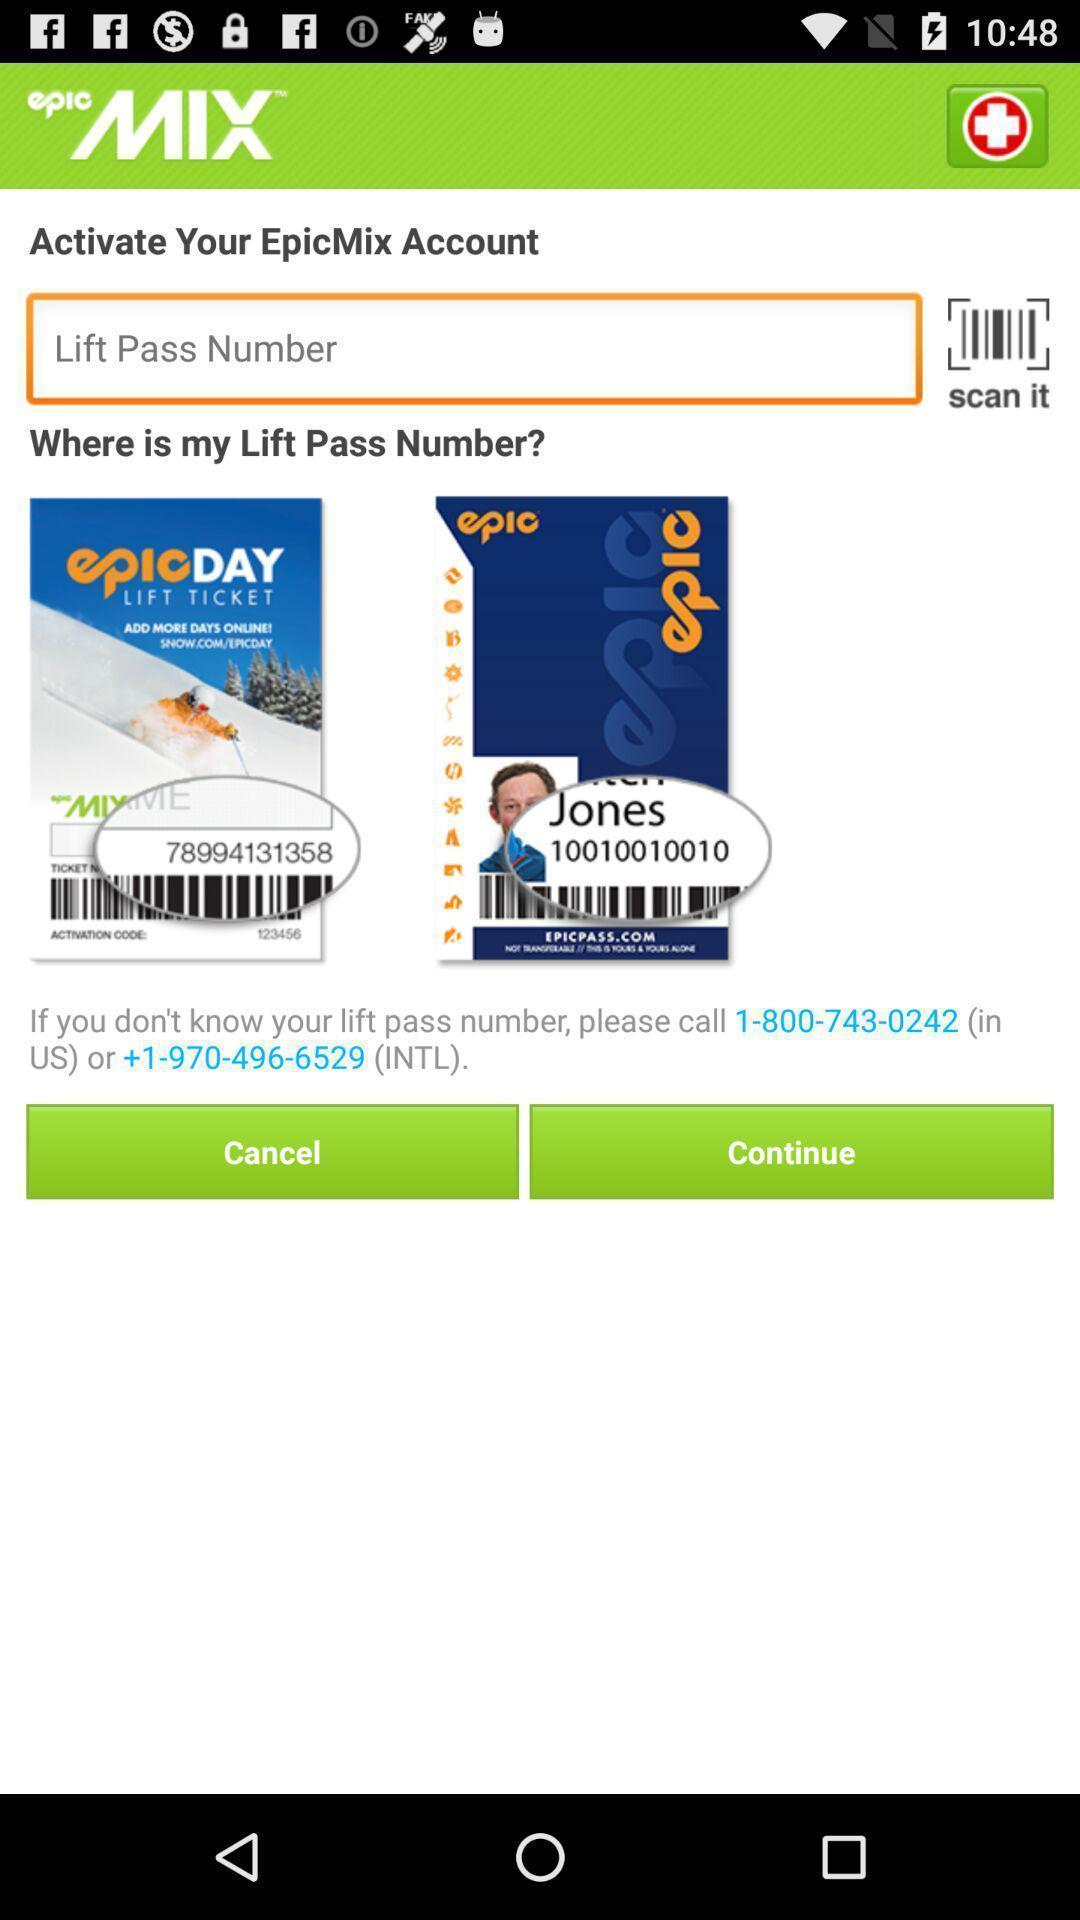Provide a textual representation of this image. Page showing the field and suggestion for lift pass number. 